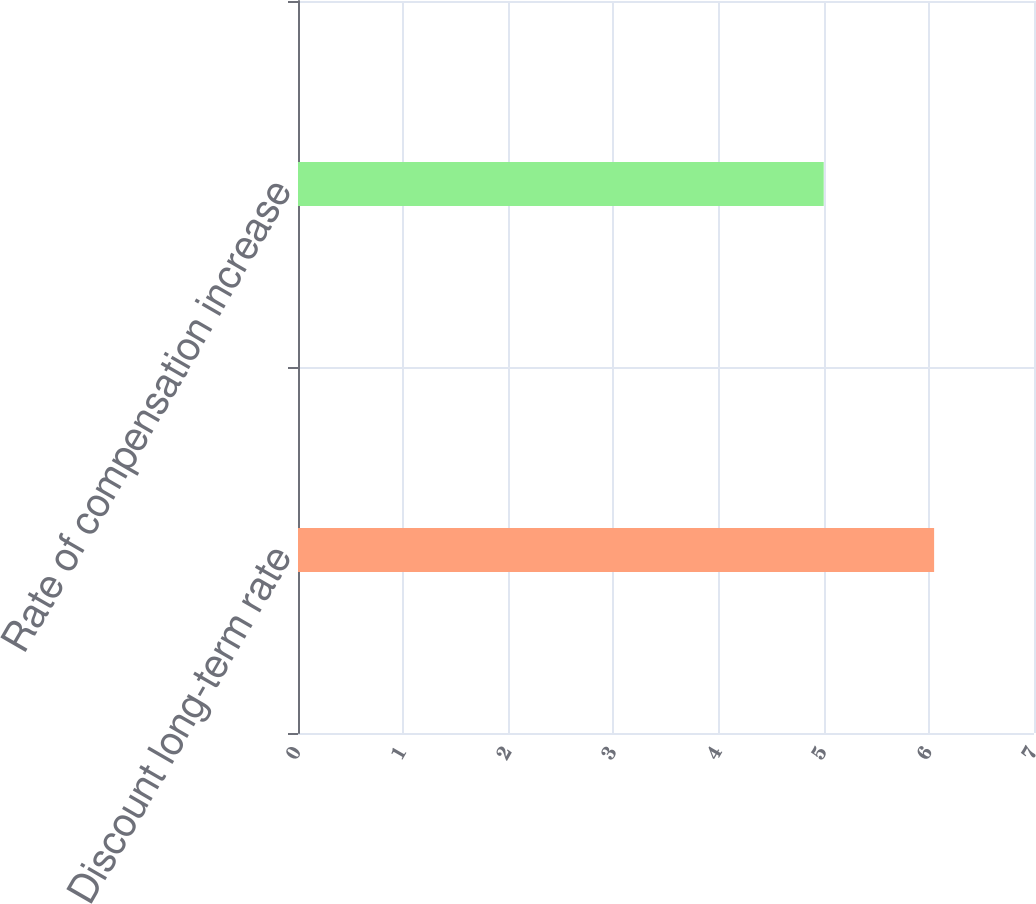Convert chart. <chart><loc_0><loc_0><loc_500><loc_500><bar_chart><fcel>Discount long-term rate<fcel>Rate of compensation increase<nl><fcel>6.05<fcel>5<nl></chart> 